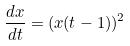<formula> <loc_0><loc_0><loc_500><loc_500>\frac { d x } { d t } = ( x ( t - 1 ) ) ^ { 2 }</formula> 